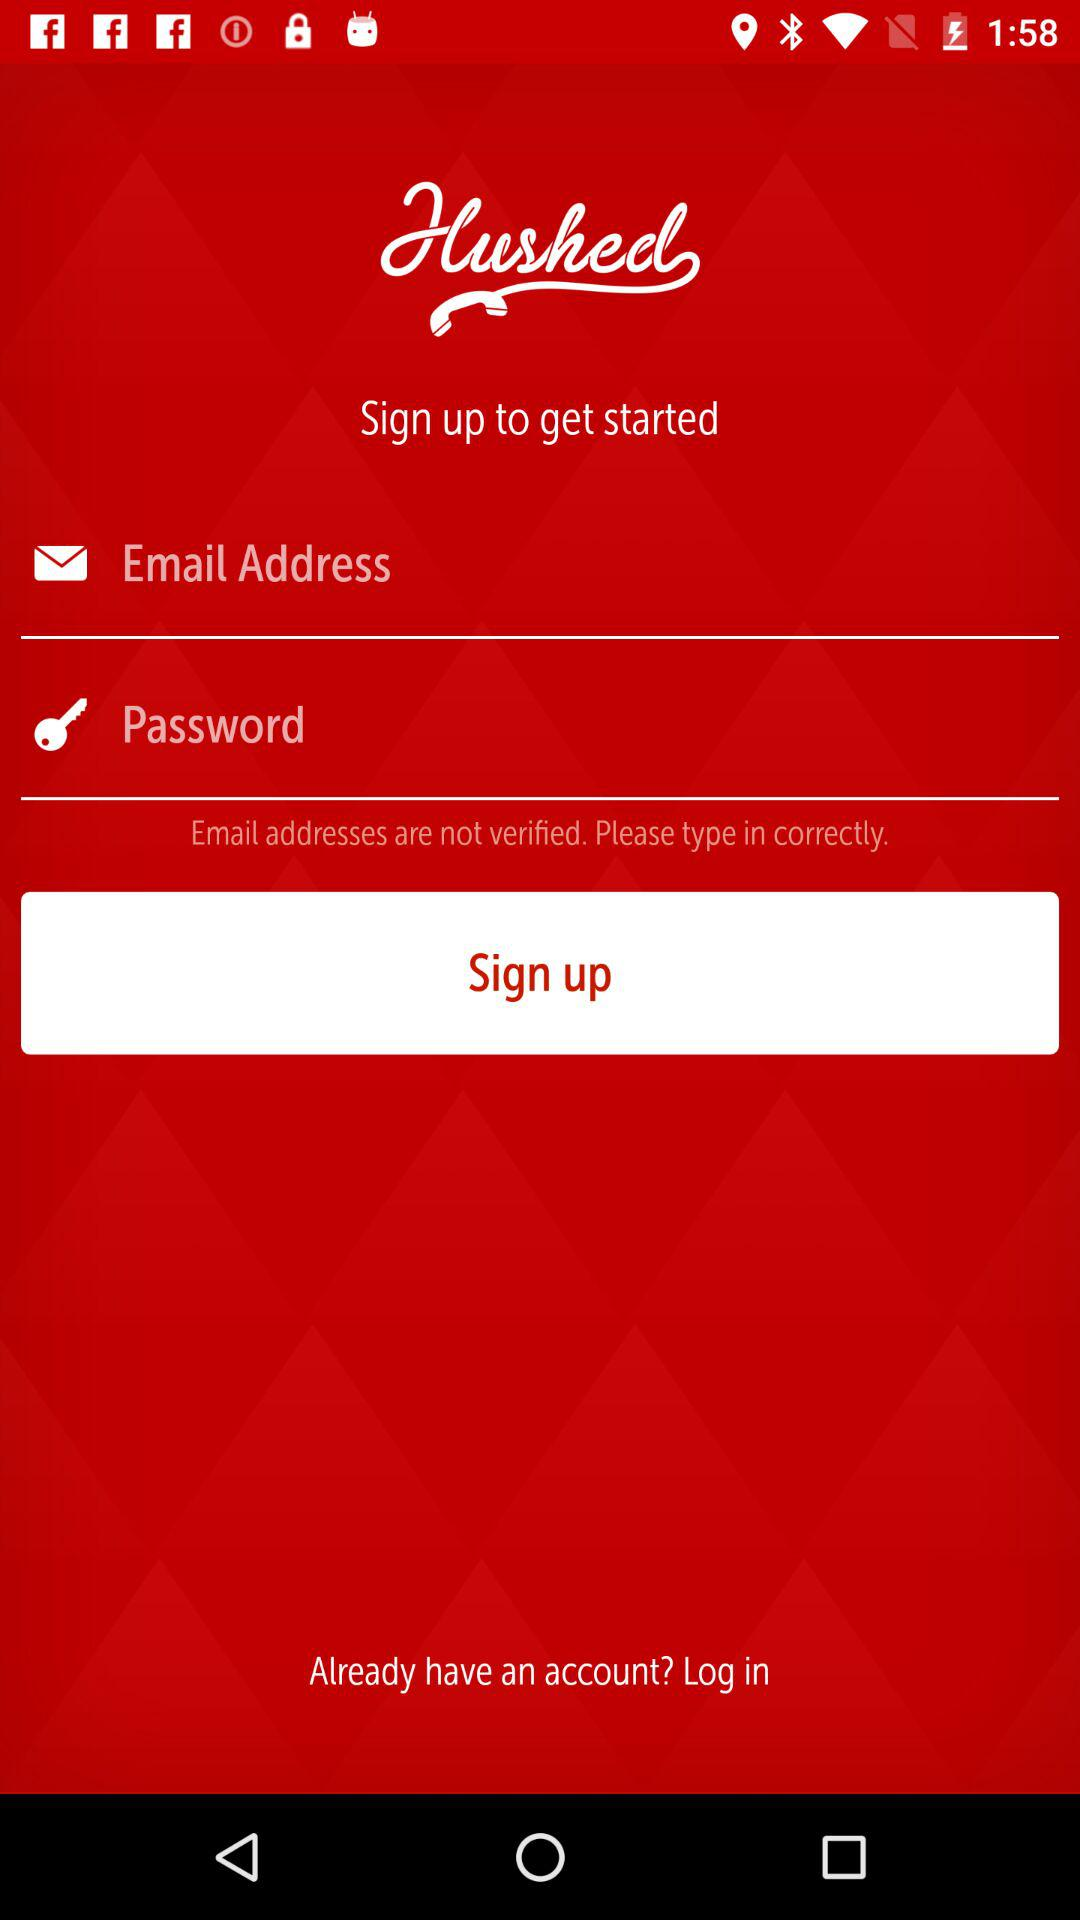What is the name of the application? The name of the application is "Hushed". 